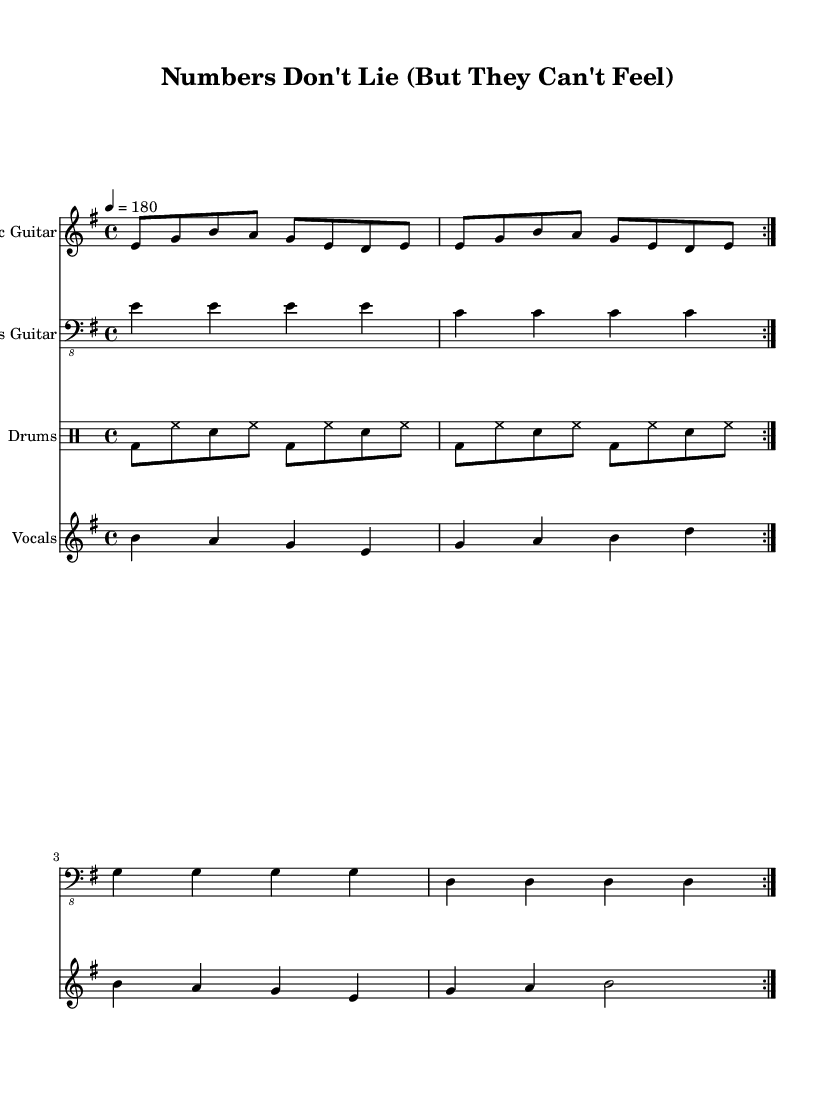What is the key signature of this music? The key signature is indicated at the beginning of the staff, showing two sharps (F# and C#), which defines the key as E minor.
Answer: E minor What is the time signature of this music? The time signature is displayed at the start of the staff as 4/4, indicating that there are four beats in each measure and the quarter note gets one beat.
Answer: 4/4 What is the tempo marking given in the sheet music? The tempo marking is noted under the global section, indicating that the performance should be at a speed of quarter note equals 180 beats per minute.
Answer: 180 How many times is the electric guitar part repeated? The electric guitar part has a marking called "volta," indicating it should be played twice, as specified in the repeat symbols.
Answer: 2 What lyrics are sung in the chorus section? The chorus contains the lines "Numbers don't lie, but they can't feel, The roar of the crowd, it's all surreal." This is indicated in the respective lyric mode in the sheet music.
Answer: Numbers don't lie, but they can't feel, The roar of the crowd, it's all surreal What instrument is notated with a bass clef? The bass guitar part is indicated with a bass clef, which is typically used for lower-pitched instruments, as seen in the staff following the instrument name.
Answer: Bass Guitar What kind of rhythmic pattern is used in the drums part? The drums part features a mixture of bass drum, hi-hat, and snare, forming a typical punk rock rhythm pattern characterized by steady eighth notes and accents on the bass and snare.
Answer: Typical punk rock rhythm 